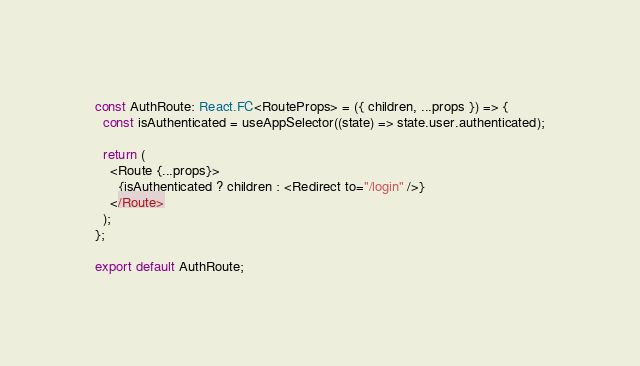Convert code to text. <code><loc_0><loc_0><loc_500><loc_500><_TypeScript_>const AuthRoute: React.FC<RouteProps> = ({ children, ...props }) => {
  const isAuthenticated = useAppSelector((state) => state.user.authenticated);

  return (
    <Route {...props}>
      {isAuthenticated ? children : <Redirect to="/login" />}
    </Route>
  );
};

export default AuthRoute;
</code> 